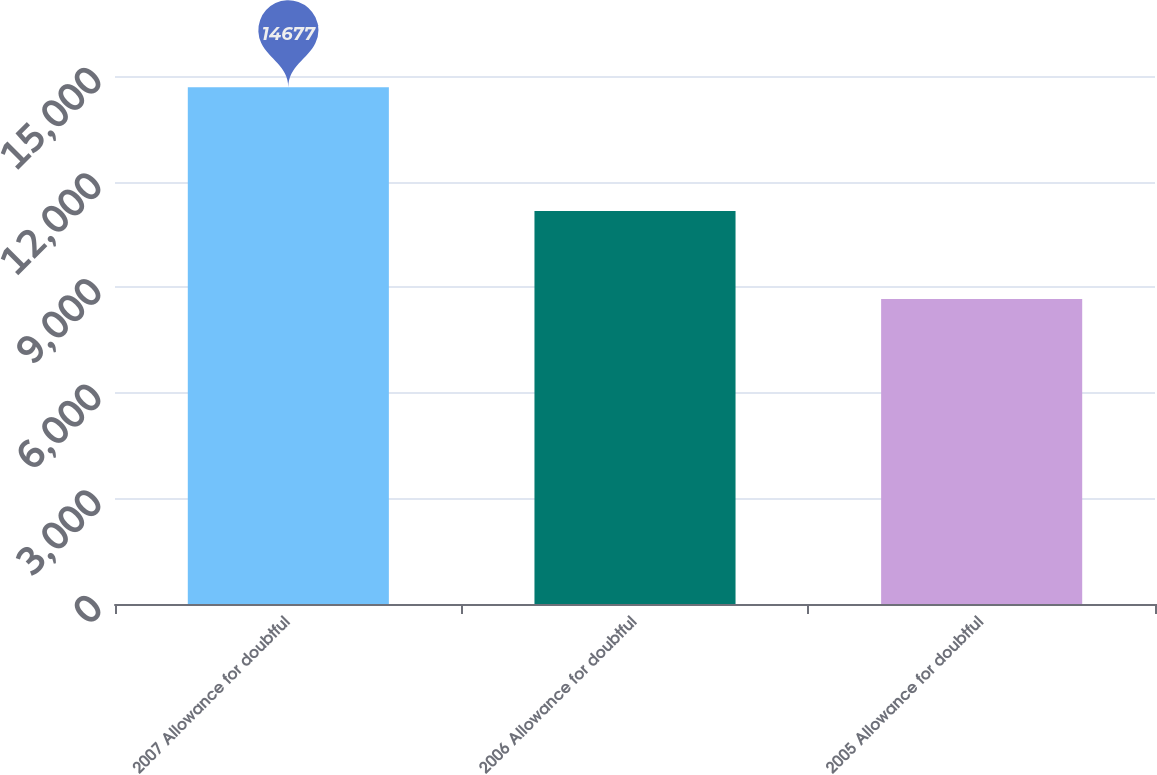Convert chart. <chart><loc_0><loc_0><loc_500><loc_500><bar_chart><fcel>2007 Allowance for doubtful<fcel>2006 Allowance for doubtful<fcel>2005 Allowance for doubtful<nl><fcel>14677<fcel>11162<fcel>8666<nl></chart> 